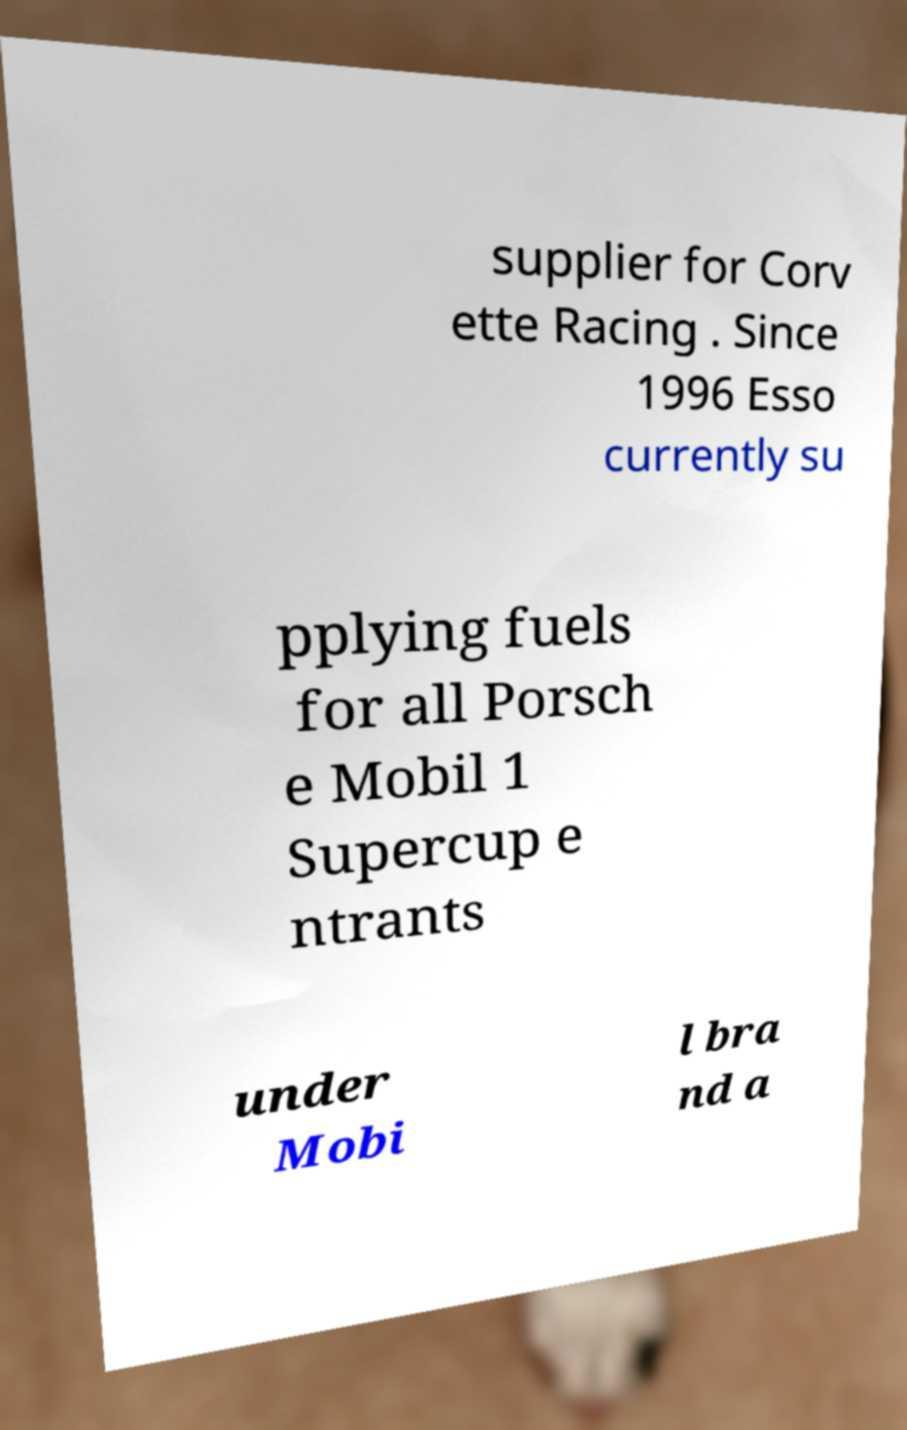Could you extract and type out the text from this image? supplier for Corv ette Racing . Since 1996 Esso currently su pplying fuels for all Porsch e Mobil 1 Supercup e ntrants under Mobi l bra nd a 